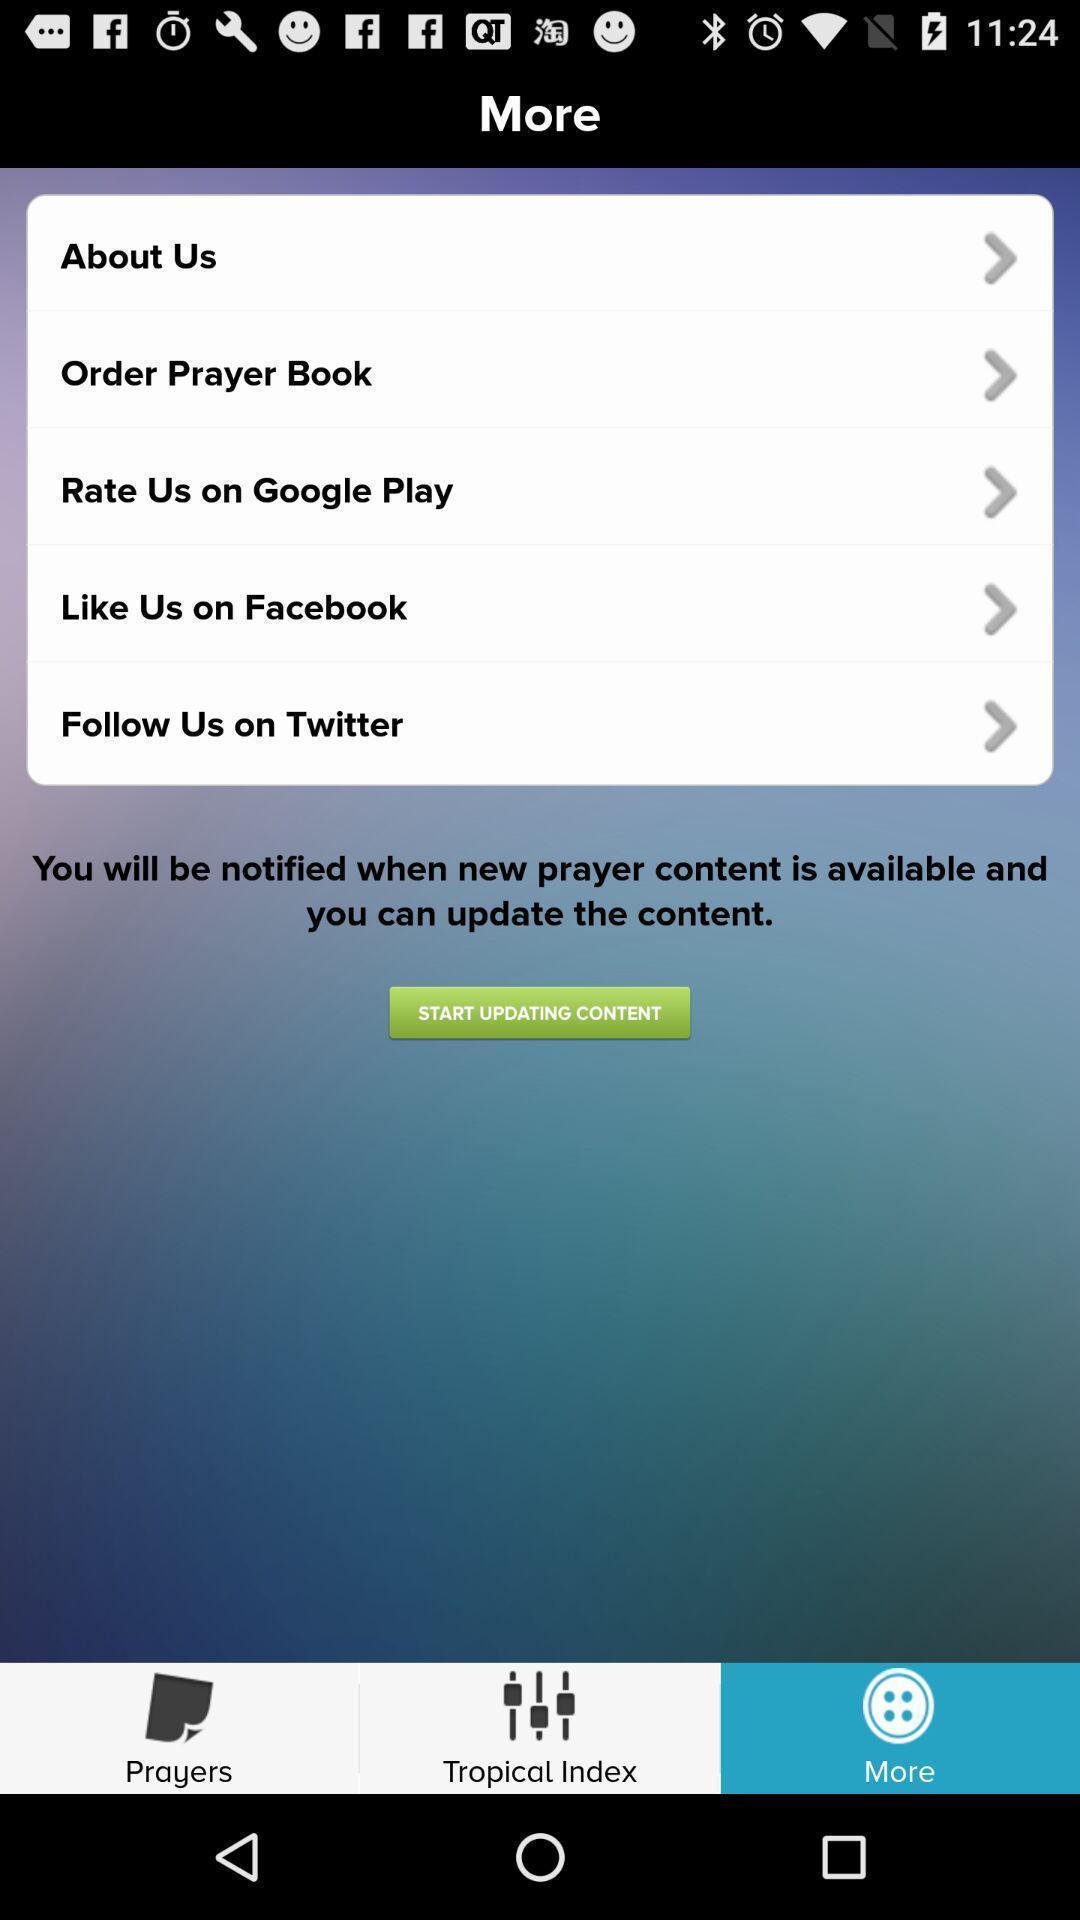Describe the content in this image. Pop-up displays more options in app. 